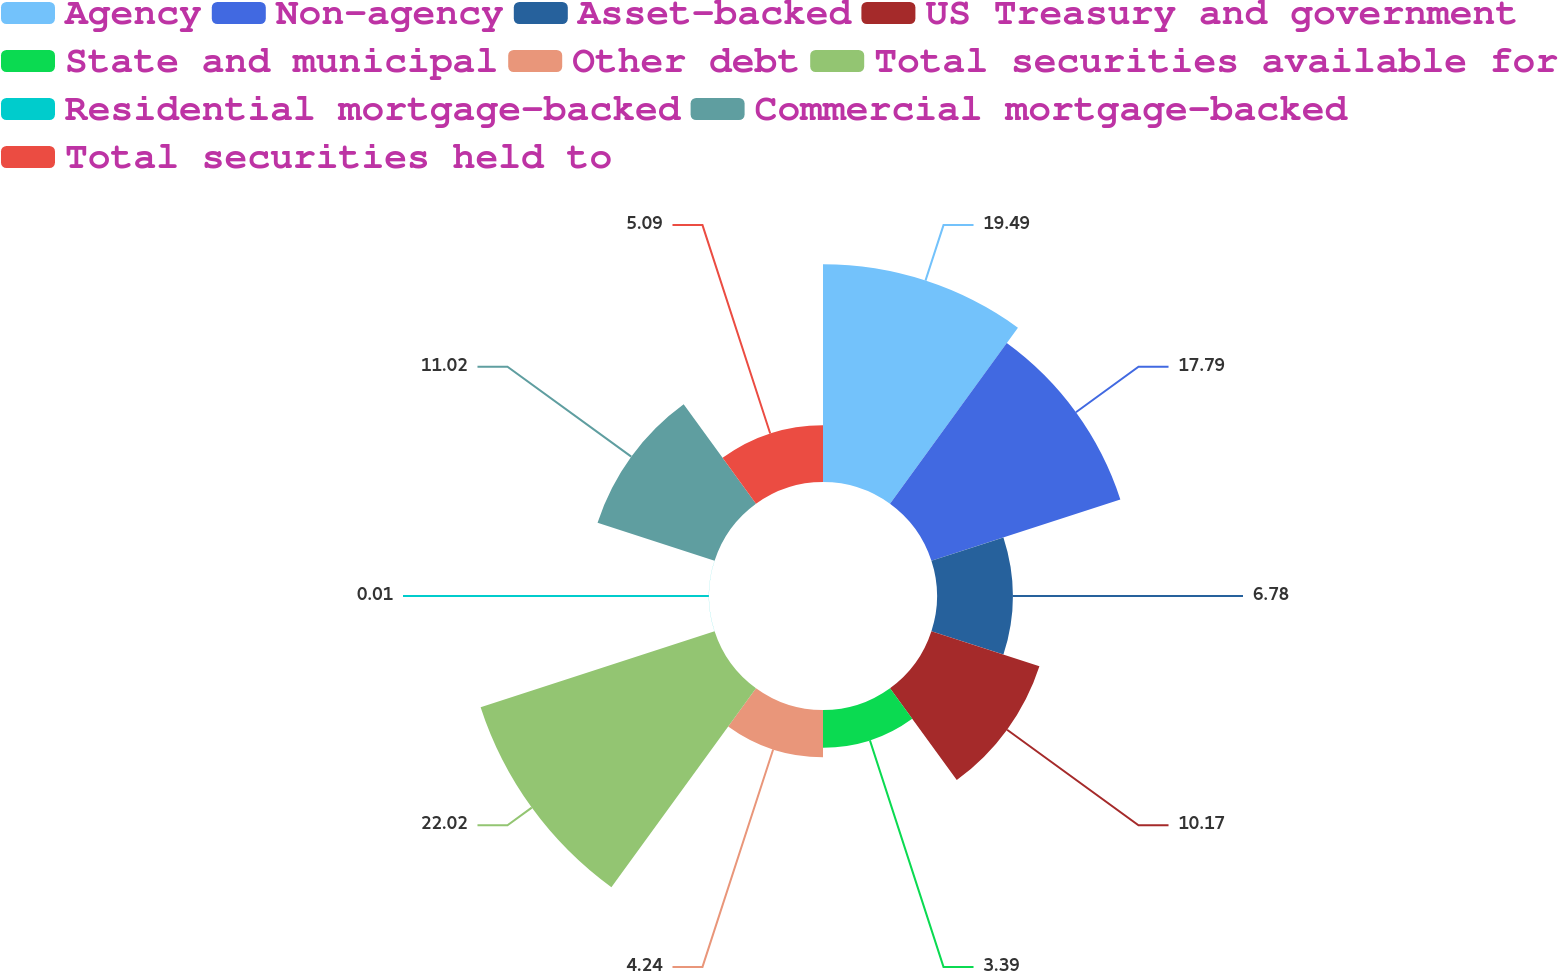Convert chart to OTSL. <chart><loc_0><loc_0><loc_500><loc_500><pie_chart><fcel>Agency<fcel>Non-agency<fcel>Asset-backed<fcel>US Treasury and government<fcel>State and municipal<fcel>Other debt<fcel>Total securities available for<fcel>Residential mortgage-backed<fcel>Commercial mortgage-backed<fcel>Total securities held to<nl><fcel>19.49%<fcel>17.79%<fcel>6.78%<fcel>10.17%<fcel>3.39%<fcel>4.24%<fcel>22.03%<fcel>0.01%<fcel>11.02%<fcel>5.09%<nl></chart> 